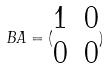Convert formula to latex. <formula><loc_0><loc_0><loc_500><loc_500>B A = ( \begin{matrix} 1 & 0 \\ 0 & 0 \end{matrix} )</formula> 